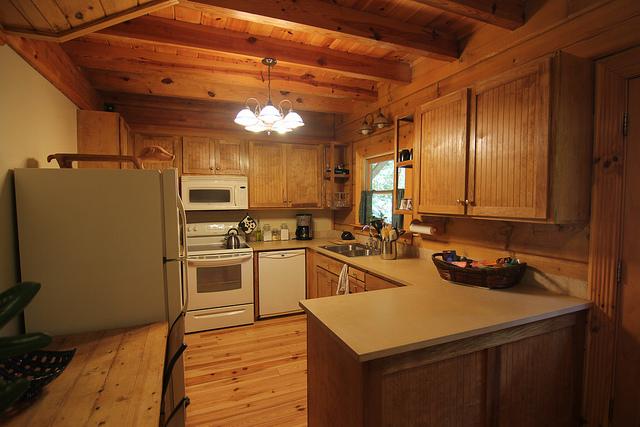Where is the glare in the picture?
Keep it brief. Cabinets. Is the room dim?
Give a very brief answer. No. What is the light hung from?
Keep it brief. Ceiling. Is the whole floor wood?
Be succinct. Yes. Is this kitchen fully functional?
Quick response, please. Yes. What's on the stove?
Concise answer only. Teapot. What kind of a flooring is there?
Concise answer only. Wood. What is that kind of tile treatment called?
Answer briefly. Wood. Where is the coffee maker in this picture?
Give a very brief answer. On counter. 